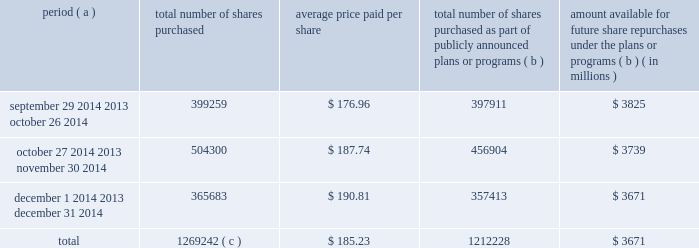Purchases of equity securities the table provides information about our repurchases of our common stock registered pursuant to section 12 of the securities exchange act of 1934 during the quarter ended december 31 , 2014 .
Period ( a ) number of shares purchased average price paid per share total number of shares purchased as part of publicly announced plans or programs ( b ) amount available for future share repurchases under the plans or programs ( b ) ( in millions ) .
Total 1269242 ( c ) $ 185.23 1212228 $ 3671 ( a ) we close our books and records on the last sunday of each month to align our financial closing with our business processes , except for the month of december , as our fiscal year ends on december 31 .
As a result , our fiscal months often differ from the calendar months .
For example , september 29 , 2014 was the first day of our october 2014 fiscal month .
( b ) in october 2010 , our board of directors approved a share repurchase program pursuant to which we are authorized to repurchase our common stock in privately negotiated transactions or in the open market at prices per share not exceeding the then-current market prices .
On september 25 , 2014 , our board of directors authorized a $ 2.0 billion increase to the program .
Under the program , management has discretion to determine the dollar amount of shares to be repurchased and the timing of any repurchases in compliance with applicable law and regulation .
We also may make purchases under the program pursuant to rule 10b5-1 plans .
The program does not have an expiration date .
( c ) during the quarter ended december 31 , 2014 , the total number of shares purchased included 57014 shares that were transferred to us by employees in satisfaction of minimum tax withholding obligations associated with the vesting of restricted stock units .
These purchases were made pursuant to a separate authorization by our board of directors and are not included within the program. .
What is the growth rate in the average price of the purchased shares from october to november 2014? 
Computations: ((187.74 - 176.96) / 176.96)
Answer: 0.06092. 